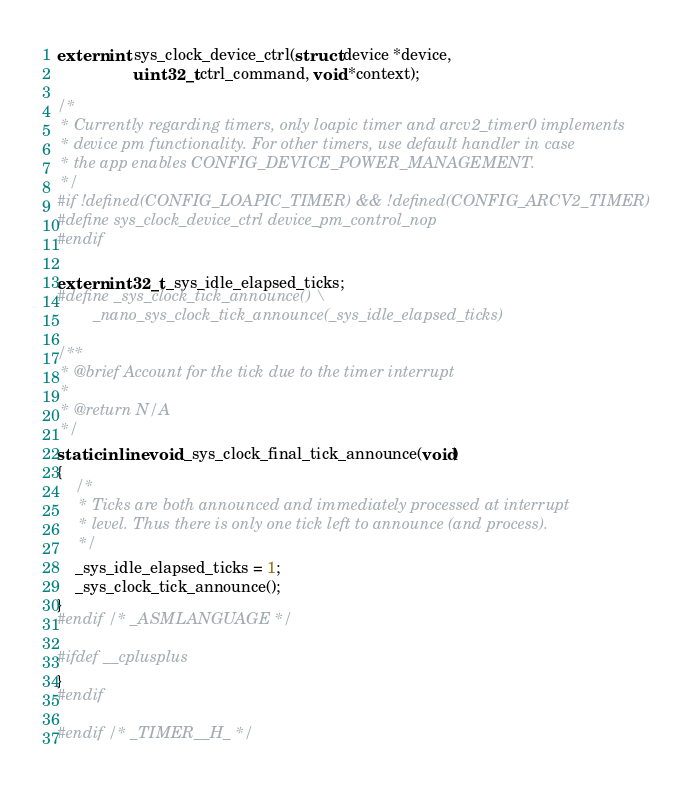<code> <loc_0><loc_0><loc_500><loc_500><_C_>extern int sys_clock_device_ctrl(struct device *device,
				 uint32_t ctrl_command, void *context);

/*
 * Currently regarding timers, only loapic timer and arcv2_timer0 implements
 * device pm functionality. For other timers, use default handler in case
 * the app enables CONFIG_DEVICE_POWER_MANAGEMENT.
 */
#if !defined(CONFIG_LOAPIC_TIMER) && !defined(CONFIG_ARCV2_TIMER)
#define sys_clock_device_ctrl device_pm_control_nop
#endif

extern int32_t _sys_idle_elapsed_ticks;
#define _sys_clock_tick_announce() \
		_nano_sys_clock_tick_announce(_sys_idle_elapsed_ticks)

/**
 * @brief Account for the tick due to the timer interrupt
 *
 * @return N/A
 */
static inline void _sys_clock_final_tick_announce(void)
{
	/*
	 * Ticks are both announced and immediately processed at interrupt
	 * level. Thus there is only one tick left to announce (and process).
	 */
	_sys_idle_elapsed_ticks = 1;
	_sys_clock_tick_announce();
}
#endif /* _ASMLANGUAGE */

#ifdef __cplusplus
}
#endif

#endif /* _TIMER__H_ */
</code> 